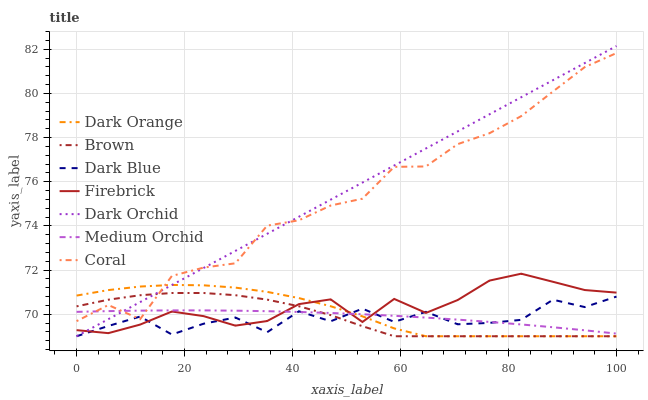Does Brown have the minimum area under the curve?
Answer yes or no. No. Does Brown have the maximum area under the curve?
Answer yes or no. No. Is Brown the smoothest?
Answer yes or no. No. Is Brown the roughest?
Answer yes or no. No. Does Firebrick have the lowest value?
Answer yes or no. No. Does Brown have the highest value?
Answer yes or no. No. Is Firebrick less than Coral?
Answer yes or no. Yes. Is Coral greater than Firebrick?
Answer yes or no. Yes. Does Firebrick intersect Coral?
Answer yes or no. No. 